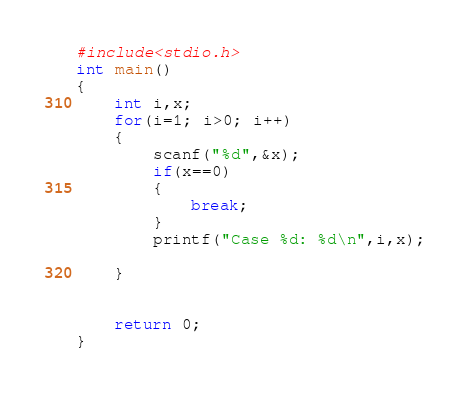<code> <loc_0><loc_0><loc_500><loc_500><_C_>#include<stdio.h>
int main()
{
    int i,x;
    for(i=1; i>0; i++)
    {
        scanf("%d",&x);
        if(x==0)
        {
            break;
        }
        printf("Case %d: %d\n",i,x);

    }


    return 0;
}


</code> 